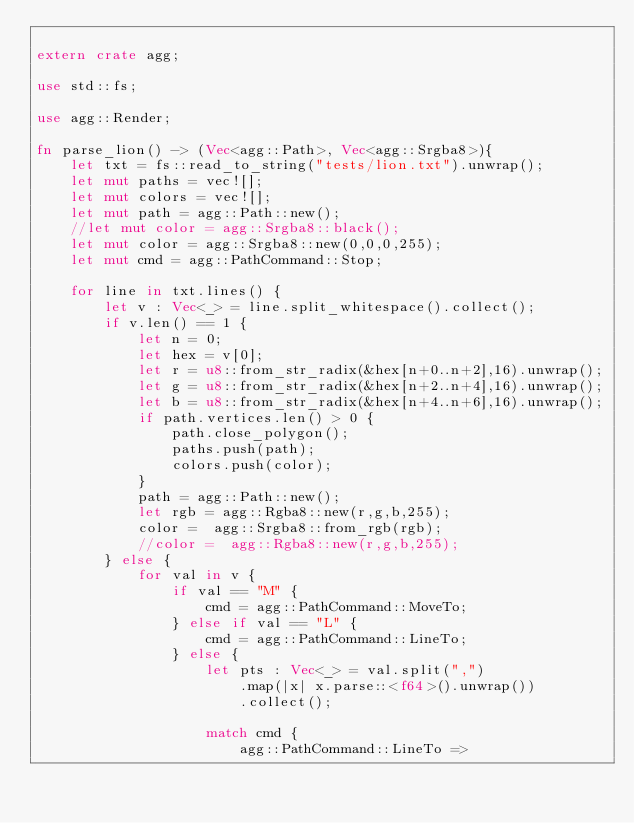Convert code to text. <code><loc_0><loc_0><loc_500><loc_500><_Rust_>
extern crate agg;

use std::fs;

use agg::Render;

fn parse_lion() -> (Vec<agg::Path>, Vec<agg::Srgba8>){
    let txt = fs::read_to_string("tests/lion.txt").unwrap();
    let mut paths = vec![];
    let mut colors = vec![];
    let mut path = agg::Path::new();
    //let mut color = agg::Srgba8::black();
    let mut color = agg::Srgba8::new(0,0,0,255);
    let mut cmd = agg::PathCommand::Stop;

    for line in txt.lines() {
        let v : Vec<_> = line.split_whitespace().collect();
        if v.len() == 1 {
            let n = 0;
            let hex = v[0];
            let r = u8::from_str_radix(&hex[n+0..n+2],16).unwrap();
            let g = u8::from_str_radix(&hex[n+2..n+4],16).unwrap();
            let b = u8::from_str_radix(&hex[n+4..n+6],16).unwrap();
            if path.vertices.len() > 0 {
                path.close_polygon();
                paths.push(path);
                colors.push(color);
            }
            path = agg::Path::new();
            let rgb = agg::Rgba8::new(r,g,b,255);
            color =  agg::Srgba8::from_rgb(rgb);
            //color =  agg::Rgba8::new(r,g,b,255);
        } else {
            for val in v {
                if val == "M" {
                    cmd = agg::PathCommand::MoveTo;
                } else if val == "L" {
                    cmd = agg::PathCommand::LineTo;
                } else {
                    let pts : Vec<_> = val.split(",")
                        .map(|x| x.parse::<f64>().unwrap())
                        .collect();

                    match cmd {
                        agg::PathCommand::LineTo =></code> 